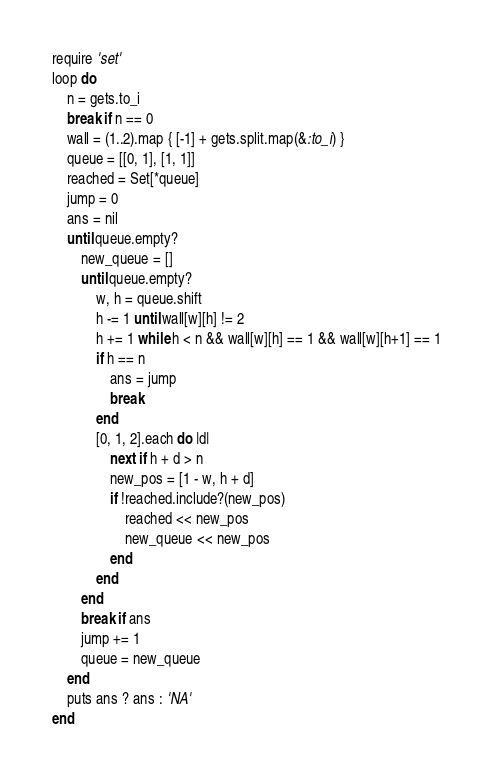<code> <loc_0><loc_0><loc_500><loc_500><_Ruby_>require 'set'
loop do
    n = gets.to_i
    break if n == 0
    wall = (1..2).map { [-1] + gets.split.map(&:to_i) }
    queue = [[0, 1], [1, 1]]
    reached = Set[*queue]
    jump = 0
    ans = nil
    until queue.empty?
        new_queue = []
        until queue.empty?
            w, h = queue.shift
            h -= 1 until wall[w][h] != 2
            h += 1 while h < n && wall[w][h] == 1 && wall[w][h+1] == 1
            if h == n
                ans = jump
                break
            end
            [0, 1, 2].each do |d|
                next if h + d > n
                new_pos = [1 - w, h + d]
                if !reached.include?(new_pos)
                    reached << new_pos
                    new_queue << new_pos
                end
            end
        end
        break if ans
        jump += 1
        queue = new_queue
    end
    puts ans ? ans : 'NA'
end

</code> 